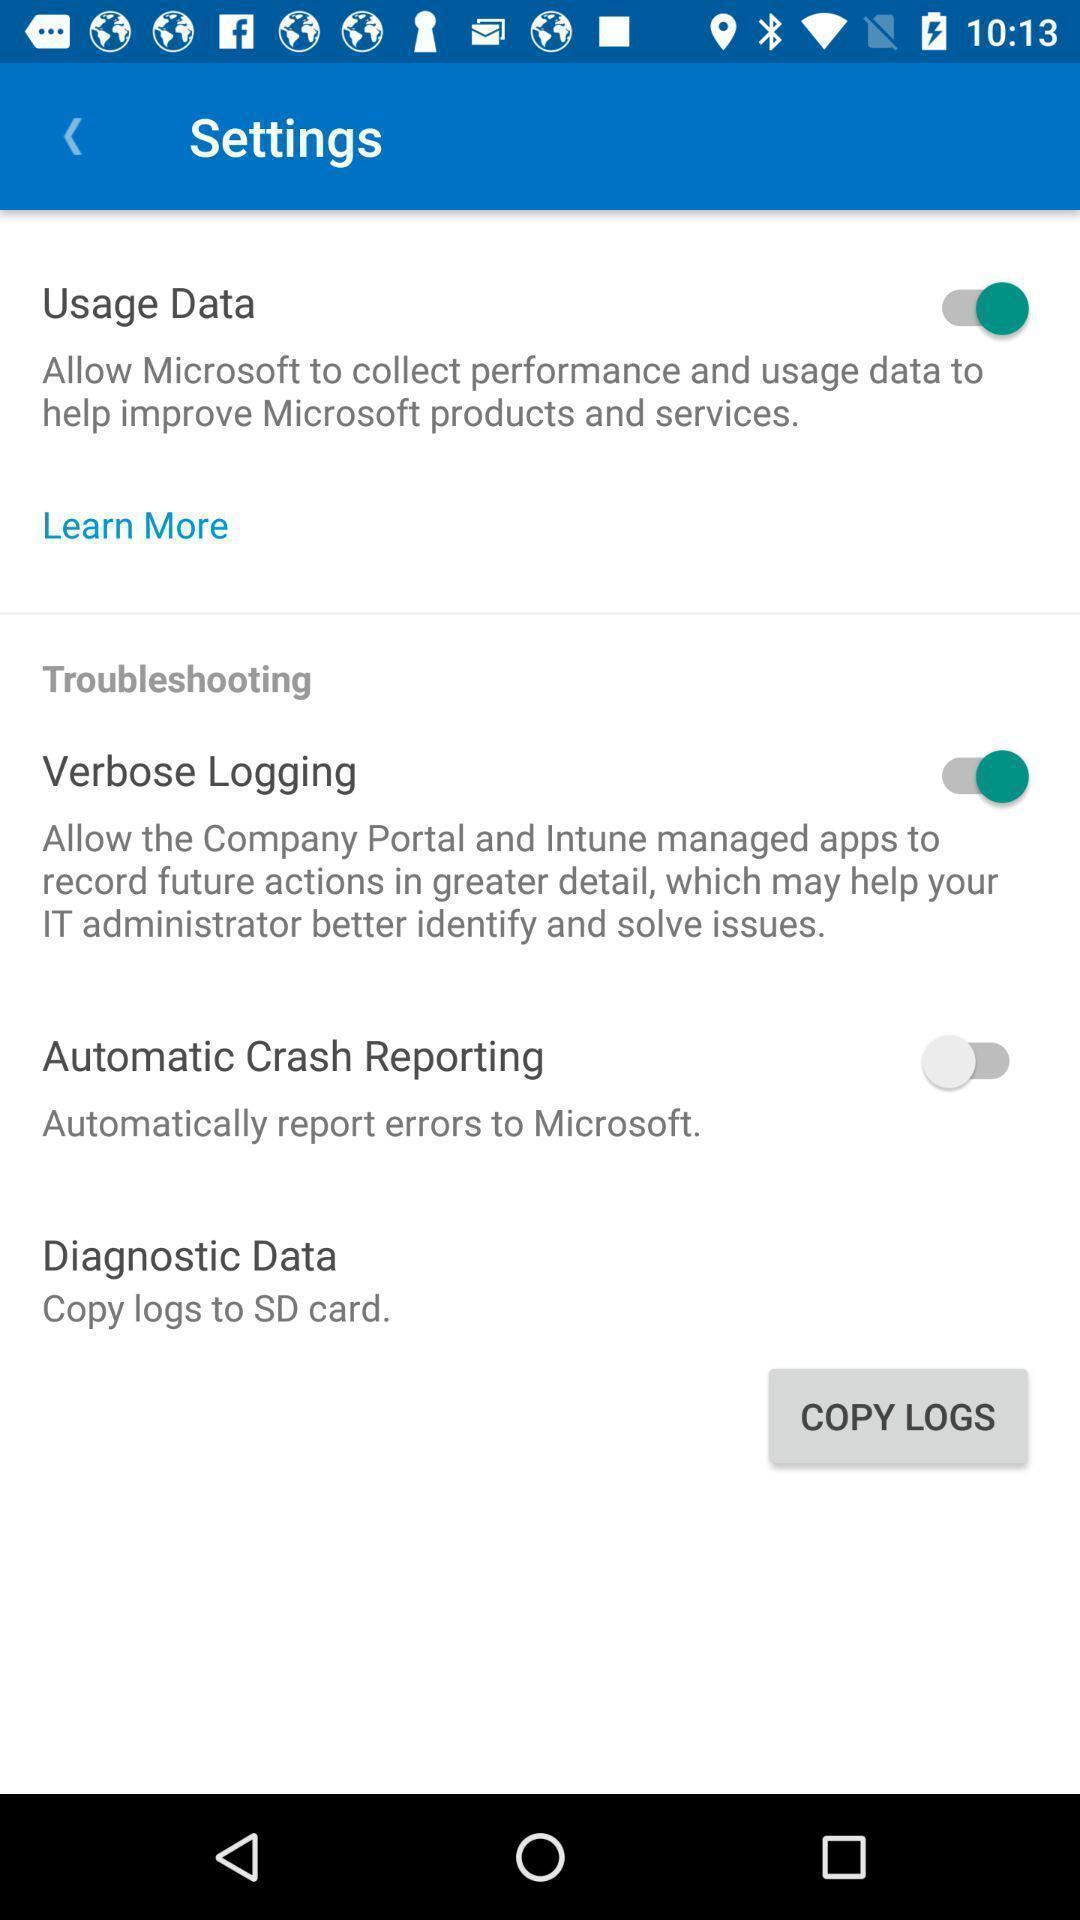Explain the elements present in this screenshot. Settings page of a corporate app. 